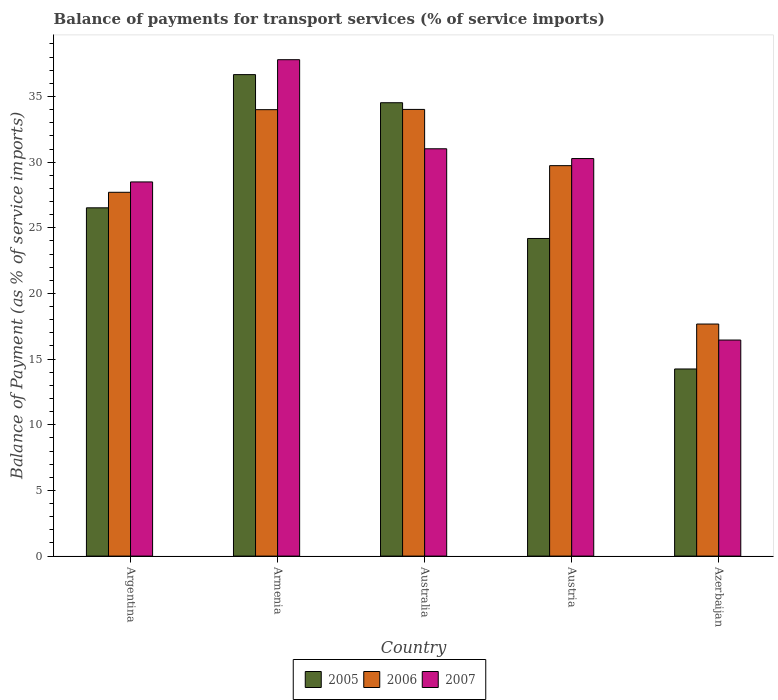How many different coloured bars are there?
Give a very brief answer. 3. How many groups of bars are there?
Provide a succinct answer. 5. How many bars are there on the 5th tick from the left?
Make the answer very short. 3. How many bars are there on the 5th tick from the right?
Provide a succinct answer. 3. What is the label of the 1st group of bars from the left?
Give a very brief answer. Argentina. In how many cases, is the number of bars for a given country not equal to the number of legend labels?
Keep it short and to the point. 0. What is the balance of payments for transport services in 2007 in Armenia?
Ensure brevity in your answer.  37.8. Across all countries, what is the maximum balance of payments for transport services in 2007?
Offer a very short reply. 37.8. Across all countries, what is the minimum balance of payments for transport services in 2005?
Ensure brevity in your answer.  14.25. In which country was the balance of payments for transport services in 2005 maximum?
Your answer should be compact. Armenia. In which country was the balance of payments for transport services in 2006 minimum?
Your response must be concise. Azerbaijan. What is the total balance of payments for transport services in 2006 in the graph?
Ensure brevity in your answer.  143.13. What is the difference between the balance of payments for transport services in 2007 in Australia and that in Austria?
Offer a very short reply. 0.74. What is the difference between the balance of payments for transport services in 2005 in Armenia and the balance of payments for transport services in 2006 in Austria?
Your answer should be very brief. 6.93. What is the average balance of payments for transport services in 2007 per country?
Provide a succinct answer. 28.81. What is the difference between the balance of payments for transport services of/in 2005 and balance of payments for transport services of/in 2006 in Australia?
Your answer should be very brief. 0.51. What is the ratio of the balance of payments for transport services in 2007 in Armenia to that in Austria?
Your answer should be compact. 1.25. Is the difference between the balance of payments for transport services in 2005 in Armenia and Austria greater than the difference between the balance of payments for transport services in 2006 in Armenia and Austria?
Ensure brevity in your answer.  Yes. What is the difference between the highest and the second highest balance of payments for transport services in 2005?
Your answer should be very brief. 8. What is the difference between the highest and the lowest balance of payments for transport services in 2006?
Provide a short and direct response. 16.34. In how many countries, is the balance of payments for transport services in 2006 greater than the average balance of payments for transport services in 2006 taken over all countries?
Offer a terse response. 3. Is the sum of the balance of payments for transport services in 2007 in Argentina and Australia greater than the maximum balance of payments for transport services in 2005 across all countries?
Make the answer very short. Yes. What does the 2nd bar from the left in Armenia represents?
Provide a short and direct response. 2006. Is it the case that in every country, the sum of the balance of payments for transport services in 2007 and balance of payments for transport services in 2006 is greater than the balance of payments for transport services in 2005?
Provide a succinct answer. Yes. Are all the bars in the graph horizontal?
Give a very brief answer. No. Does the graph contain any zero values?
Your answer should be very brief. No. How are the legend labels stacked?
Your answer should be very brief. Horizontal. What is the title of the graph?
Make the answer very short. Balance of payments for transport services (% of service imports). Does "1991" appear as one of the legend labels in the graph?
Offer a terse response. No. What is the label or title of the X-axis?
Your answer should be compact. Country. What is the label or title of the Y-axis?
Your response must be concise. Balance of Payment (as % of service imports). What is the Balance of Payment (as % of service imports) in 2005 in Argentina?
Provide a short and direct response. 26.52. What is the Balance of Payment (as % of service imports) in 2006 in Argentina?
Your answer should be compact. 27.71. What is the Balance of Payment (as % of service imports) of 2007 in Argentina?
Provide a short and direct response. 28.49. What is the Balance of Payment (as % of service imports) of 2005 in Armenia?
Give a very brief answer. 36.67. What is the Balance of Payment (as % of service imports) of 2006 in Armenia?
Keep it short and to the point. 34. What is the Balance of Payment (as % of service imports) of 2007 in Armenia?
Keep it short and to the point. 37.8. What is the Balance of Payment (as % of service imports) in 2005 in Australia?
Offer a very short reply. 34.53. What is the Balance of Payment (as % of service imports) of 2006 in Australia?
Provide a short and direct response. 34.02. What is the Balance of Payment (as % of service imports) of 2007 in Australia?
Your answer should be compact. 31.02. What is the Balance of Payment (as % of service imports) in 2005 in Austria?
Make the answer very short. 24.19. What is the Balance of Payment (as % of service imports) of 2006 in Austria?
Ensure brevity in your answer.  29.73. What is the Balance of Payment (as % of service imports) of 2007 in Austria?
Provide a succinct answer. 30.27. What is the Balance of Payment (as % of service imports) in 2005 in Azerbaijan?
Make the answer very short. 14.25. What is the Balance of Payment (as % of service imports) of 2006 in Azerbaijan?
Make the answer very short. 17.67. What is the Balance of Payment (as % of service imports) in 2007 in Azerbaijan?
Keep it short and to the point. 16.45. Across all countries, what is the maximum Balance of Payment (as % of service imports) of 2005?
Your answer should be very brief. 36.67. Across all countries, what is the maximum Balance of Payment (as % of service imports) of 2006?
Give a very brief answer. 34.02. Across all countries, what is the maximum Balance of Payment (as % of service imports) of 2007?
Offer a very short reply. 37.8. Across all countries, what is the minimum Balance of Payment (as % of service imports) of 2005?
Keep it short and to the point. 14.25. Across all countries, what is the minimum Balance of Payment (as % of service imports) in 2006?
Keep it short and to the point. 17.67. Across all countries, what is the minimum Balance of Payment (as % of service imports) of 2007?
Provide a short and direct response. 16.45. What is the total Balance of Payment (as % of service imports) in 2005 in the graph?
Offer a terse response. 136.15. What is the total Balance of Payment (as % of service imports) of 2006 in the graph?
Make the answer very short. 143.13. What is the total Balance of Payment (as % of service imports) in 2007 in the graph?
Offer a terse response. 144.05. What is the difference between the Balance of Payment (as % of service imports) in 2005 in Argentina and that in Armenia?
Your answer should be very brief. -10.14. What is the difference between the Balance of Payment (as % of service imports) of 2006 in Argentina and that in Armenia?
Offer a very short reply. -6.29. What is the difference between the Balance of Payment (as % of service imports) of 2007 in Argentina and that in Armenia?
Offer a terse response. -9.31. What is the difference between the Balance of Payment (as % of service imports) of 2005 in Argentina and that in Australia?
Make the answer very short. -8. What is the difference between the Balance of Payment (as % of service imports) of 2006 in Argentina and that in Australia?
Offer a terse response. -6.31. What is the difference between the Balance of Payment (as % of service imports) of 2007 in Argentina and that in Australia?
Your response must be concise. -2.53. What is the difference between the Balance of Payment (as % of service imports) of 2005 in Argentina and that in Austria?
Provide a succinct answer. 2.33. What is the difference between the Balance of Payment (as % of service imports) of 2006 in Argentina and that in Austria?
Keep it short and to the point. -2.03. What is the difference between the Balance of Payment (as % of service imports) of 2007 in Argentina and that in Austria?
Keep it short and to the point. -1.78. What is the difference between the Balance of Payment (as % of service imports) in 2005 in Argentina and that in Azerbaijan?
Keep it short and to the point. 12.27. What is the difference between the Balance of Payment (as % of service imports) in 2006 in Argentina and that in Azerbaijan?
Make the answer very short. 10.03. What is the difference between the Balance of Payment (as % of service imports) of 2007 in Argentina and that in Azerbaijan?
Offer a terse response. 12.04. What is the difference between the Balance of Payment (as % of service imports) in 2005 in Armenia and that in Australia?
Your answer should be compact. 2.14. What is the difference between the Balance of Payment (as % of service imports) in 2006 in Armenia and that in Australia?
Provide a short and direct response. -0.02. What is the difference between the Balance of Payment (as % of service imports) in 2007 in Armenia and that in Australia?
Keep it short and to the point. 6.78. What is the difference between the Balance of Payment (as % of service imports) in 2005 in Armenia and that in Austria?
Keep it short and to the point. 12.48. What is the difference between the Balance of Payment (as % of service imports) in 2006 in Armenia and that in Austria?
Ensure brevity in your answer.  4.26. What is the difference between the Balance of Payment (as % of service imports) of 2007 in Armenia and that in Austria?
Offer a very short reply. 7.53. What is the difference between the Balance of Payment (as % of service imports) of 2005 in Armenia and that in Azerbaijan?
Make the answer very short. 22.42. What is the difference between the Balance of Payment (as % of service imports) in 2006 in Armenia and that in Azerbaijan?
Give a very brief answer. 16.33. What is the difference between the Balance of Payment (as % of service imports) in 2007 in Armenia and that in Azerbaijan?
Ensure brevity in your answer.  21.35. What is the difference between the Balance of Payment (as % of service imports) of 2005 in Australia and that in Austria?
Offer a terse response. 10.34. What is the difference between the Balance of Payment (as % of service imports) in 2006 in Australia and that in Austria?
Your answer should be compact. 4.28. What is the difference between the Balance of Payment (as % of service imports) in 2007 in Australia and that in Austria?
Provide a short and direct response. 0.74. What is the difference between the Balance of Payment (as % of service imports) of 2005 in Australia and that in Azerbaijan?
Provide a short and direct response. 20.28. What is the difference between the Balance of Payment (as % of service imports) of 2006 in Australia and that in Azerbaijan?
Provide a succinct answer. 16.34. What is the difference between the Balance of Payment (as % of service imports) in 2007 in Australia and that in Azerbaijan?
Offer a very short reply. 14.57. What is the difference between the Balance of Payment (as % of service imports) of 2005 in Austria and that in Azerbaijan?
Your answer should be very brief. 9.94. What is the difference between the Balance of Payment (as % of service imports) of 2006 in Austria and that in Azerbaijan?
Give a very brief answer. 12.06. What is the difference between the Balance of Payment (as % of service imports) in 2007 in Austria and that in Azerbaijan?
Offer a terse response. 13.82. What is the difference between the Balance of Payment (as % of service imports) of 2005 in Argentina and the Balance of Payment (as % of service imports) of 2006 in Armenia?
Give a very brief answer. -7.47. What is the difference between the Balance of Payment (as % of service imports) of 2005 in Argentina and the Balance of Payment (as % of service imports) of 2007 in Armenia?
Provide a short and direct response. -11.28. What is the difference between the Balance of Payment (as % of service imports) of 2006 in Argentina and the Balance of Payment (as % of service imports) of 2007 in Armenia?
Your response must be concise. -10.1. What is the difference between the Balance of Payment (as % of service imports) in 2005 in Argentina and the Balance of Payment (as % of service imports) in 2006 in Australia?
Offer a very short reply. -7.49. What is the difference between the Balance of Payment (as % of service imports) in 2005 in Argentina and the Balance of Payment (as % of service imports) in 2007 in Australia?
Provide a succinct answer. -4.5. What is the difference between the Balance of Payment (as % of service imports) in 2006 in Argentina and the Balance of Payment (as % of service imports) in 2007 in Australia?
Keep it short and to the point. -3.31. What is the difference between the Balance of Payment (as % of service imports) of 2005 in Argentina and the Balance of Payment (as % of service imports) of 2006 in Austria?
Provide a succinct answer. -3.21. What is the difference between the Balance of Payment (as % of service imports) of 2005 in Argentina and the Balance of Payment (as % of service imports) of 2007 in Austria?
Your response must be concise. -3.75. What is the difference between the Balance of Payment (as % of service imports) in 2006 in Argentina and the Balance of Payment (as % of service imports) in 2007 in Austria?
Ensure brevity in your answer.  -2.57. What is the difference between the Balance of Payment (as % of service imports) of 2005 in Argentina and the Balance of Payment (as % of service imports) of 2006 in Azerbaijan?
Your answer should be very brief. 8.85. What is the difference between the Balance of Payment (as % of service imports) in 2005 in Argentina and the Balance of Payment (as % of service imports) in 2007 in Azerbaijan?
Keep it short and to the point. 10.07. What is the difference between the Balance of Payment (as % of service imports) of 2006 in Argentina and the Balance of Payment (as % of service imports) of 2007 in Azerbaijan?
Your answer should be compact. 11.25. What is the difference between the Balance of Payment (as % of service imports) in 2005 in Armenia and the Balance of Payment (as % of service imports) in 2006 in Australia?
Provide a short and direct response. 2.65. What is the difference between the Balance of Payment (as % of service imports) in 2005 in Armenia and the Balance of Payment (as % of service imports) in 2007 in Australia?
Make the answer very short. 5.65. What is the difference between the Balance of Payment (as % of service imports) in 2006 in Armenia and the Balance of Payment (as % of service imports) in 2007 in Australia?
Your response must be concise. 2.98. What is the difference between the Balance of Payment (as % of service imports) in 2005 in Armenia and the Balance of Payment (as % of service imports) in 2006 in Austria?
Provide a short and direct response. 6.93. What is the difference between the Balance of Payment (as % of service imports) in 2005 in Armenia and the Balance of Payment (as % of service imports) in 2007 in Austria?
Make the answer very short. 6.39. What is the difference between the Balance of Payment (as % of service imports) of 2006 in Armenia and the Balance of Payment (as % of service imports) of 2007 in Austria?
Keep it short and to the point. 3.72. What is the difference between the Balance of Payment (as % of service imports) of 2005 in Armenia and the Balance of Payment (as % of service imports) of 2006 in Azerbaijan?
Give a very brief answer. 18.99. What is the difference between the Balance of Payment (as % of service imports) in 2005 in Armenia and the Balance of Payment (as % of service imports) in 2007 in Azerbaijan?
Ensure brevity in your answer.  20.21. What is the difference between the Balance of Payment (as % of service imports) in 2006 in Armenia and the Balance of Payment (as % of service imports) in 2007 in Azerbaijan?
Your answer should be compact. 17.54. What is the difference between the Balance of Payment (as % of service imports) of 2005 in Australia and the Balance of Payment (as % of service imports) of 2006 in Austria?
Make the answer very short. 4.79. What is the difference between the Balance of Payment (as % of service imports) in 2005 in Australia and the Balance of Payment (as % of service imports) in 2007 in Austria?
Provide a short and direct response. 4.25. What is the difference between the Balance of Payment (as % of service imports) of 2006 in Australia and the Balance of Payment (as % of service imports) of 2007 in Austria?
Your response must be concise. 3.74. What is the difference between the Balance of Payment (as % of service imports) of 2005 in Australia and the Balance of Payment (as % of service imports) of 2006 in Azerbaijan?
Keep it short and to the point. 16.85. What is the difference between the Balance of Payment (as % of service imports) of 2005 in Australia and the Balance of Payment (as % of service imports) of 2007 in Azerbaijan?
Make the answer very short. 18.07. What is the difference between the Balance of Payment (as % of service imports) of 2006 in Australia and the Balance of Payment (as % of service imports) of 2007 in Azerbaijan?
Offer a terse response. 17.56. What is the difference between the Balance of Payment (as % of service imports) of 2005 in Austria and the Balance of Payment (as % of service imports) of 2006 in Azerbaijan?
Make the answer very short. 6.52. What is the difference between the Balance of Payment (as % of service imports) in 2005 in Austria and the Balance of Payment (as % of service imports) in 2007 in Azerbaijan?
Provide a short and direct response. 7.73. What is the difference between the Balance of Payment (as % of service imports) in 2006 in Austria and the Balance of Payment (as % of service imports) in 2007 in Azerbaijan?
Offer a very short reply. 13.28. What is the average Balance of Payment (as % of service imports) of 2005 per country?
Provide a short and direct response. 27.23. What is the average Balance of Payment (as % of service imports) of 2006 per country?
Your answer should be very brief. 28.63. What is the average Balance of Payment (as % of service imports) of 2007 per country?
Your answer should be compact. 28.81. What is the difference between the Balance of Payment (as % of service imports) in 2005 and Balance of Payment (as % of service imports) in 2006 in Argentina?
Your answer should be very brief. -1.18. What is the difference between the Balance of Payment (as % of service imports) in 2005 and Balance of Payment (as % of service imports) in 2007 in Argentina?
Offer a very short reply. -1.97. What is the difference between the Balance of Payment (as % of service imports) in 2006 and Balance of Payment (as % of service imports) in 2007 in Argentina?
Provide a succinct answer. -0.79. What is the difference between the Balance of Payment (as % of service imports) of 2005 and Balance of Payment (as % of service imports) of 2006 in Armenia?
Provide a succinct answer. 2.67. What is the difference between the Balance of Payment (as % of service imports) of 2005 and Balance of Payment (as % of service imports) of 2007 in Armenia?
Your answer should be compact. -1.14. What is the difference between the Balance of Payment (as % of service imports) in 2006 and Balance of Payment (as % of service imports) in 2007 in Armenia?
Offer a terse response. -3.8. What is the difference between the Balance of Payment (as % of service imports) of 2005 and Balance of Payment (as % of service imports) of 2006 in Australia?
Offer a very short reply. 0.51. What is the difference between the Balance of Payment (as % of service imports) of 2005 and Balance of Payment (as % of service imports) of 2007 in Australia?
Your answer should be very brief. 3.51. What is the difference between the Balance of Payment (as % of service imports) in 2006 and Balance of Payment (as % of service imports) in 2007 in Australia?
Provide a short and direct response. 3. What is the difference between the Balance of Payment (as % of service imports) of 2005 and Balance of Payment (as % of service imports) of 2006 in Austria?
Make the answer very short. -5.55. What is the difference between the Balance of Payment (as % of service imports) of 2005 and Balance of Payment (as % of service imports) of 2007 in Austria?
Give a very brief answer. -6.09. What is the difference between the Balance of Payment (as % of service imports) of 2006 and Balance of Payment (as % of service imports) of 2007 in Austria?
Ensure brevity in your answer.  -0.54. What is the difference between the Balance of Payment (as % of service imports) in 2005 and Balance of Payment (as % of service imports) in 2006 in Azerbaijan?
Ensure brevity in your answer.  -3.42. What is the difference between the Balance of Payment (as % of service imports) of 2005 and Balance of Payment (as % of service imports) of 2007 in Azerbaijan?
Provide a succinct answer. -2.2. What is the difference between the Balance of Payment (as % of service imports) of 2006 and Balance of Payment (as % of service imports) of 2007 in Azerbaijan?
Ensure brevity in your answer.  1.22. What is the ratio of the Balance of Payment (as % of service imports) of 2005 in Argentina to that in Armenia?
Your response must be concise. 0.72. What is the ratio of the Balance of Payment (as % of service imports) in 2006 in Argentina to that in Armenia?
Ensure brevity in your answer.  0.81. What is the ratio of the Balance of Payment (as % of service imports) in 2007 in Argentina to that in Armenia?
Offer a very short reply. 0.75. What is the ratio of the Balance of Payment (as % of service imports) in 2005 in Argentina to that in Australia?
Give a very brief answer. 0.77. What is the ratio of the Balance of Payment (as % of service imports) of 2006 in Argentina to that in Australia?
Keep it short and to the point. 0.81. What is the ratio of the Balance of Payment (as % of service imports) of 2007 in Argentina to that in Australia?
Make the answer very short. 0.92. What is the ratio of the Balance of Payment (as % of service imports) in 2005 in Argentina to that in Austria?
Offer a very short reply. 1.1. What is the ratio of the Balance of Payment (as % of service imports) in 2006 in Argentina to that in Austria?
Ensure brevity in your answer.  0.93. What is the ratio of the Balance of Payment (as % of service imports) in 2007 in Argentina to that in Austria?
Give a very brief answer. 0.94. What is the ratio of the Balance of Payment (as % of service imports) in 2005 in Argentina to that in Azerbaijan?
Your response must be concise. 1.86. What is the ratio of the Balance of Payment (as % of service imports) in 2006 in Argentina to that in Azerbaijan?
Offer a very short reply. 1.57. What is the ratio of the Balance of Payment (as % of service imports) of 2007 in Argentina to that in Azerbaijan?
Your answer should be very brief. 1.73. What is the ratio of the Balance of Payment (as % of service imports) of 2005 in Armenia to that in Australia?
Ensure brevity in your answer.  1.06. What is the ratio of the Balance of Payment (as % of service imports) in 2006 in Armenia to that in Australia?
Make the answer very short. 1. What is the ratio of the Balance of Payment (as % of service imports) of 2007 in Armenia to that in Australia?
Your answer should be very brief. 1.22. What is the ratio of the Balance of Payment (as % of service imports) in 2005 in Armenia to that in Austria?
Your answer should be very brief. 1.52. What is the ratio of the Balance of Payment (as % of service imports) of 2006 in Armenia to that in Austria?
Offer a very short reply. 1.14. What is the ratio of the Balance of Payment (as % of service imports) in 2007 in Armenia to that in Austria?
Your response must be concise. 1.25. What is the ratio of the Balance of Payment (as % of service imports) of 2005 in Armenia to that in Azerbaijan?
Offer a terse response. 2.57. What is the ratio of the Balance of Payment (as % of service imports) of 2006 in Armenia to that in Azerbaijan?
Give a very brief answer. 1.92. What is the ratio of the Balance of Payment (as % of service imports) in 2007 in Armenia to that in Azerbaijan?
Keep it short and to the point. 2.3. What is the ratio of the Balance of Payment (as % of service imports) in 2005 in Australia to that in Austria?
Make the answer very short. 1.43. What is the ratio of the Balance of Payment (as % of service imports) of 2006 in Australia to that in Austria?
Your answer should be very brief. 1.14. What is the ratio of the Balance of Payment (as % of service imports) in 2007 in Australia to that in Austria?
Give a very brief answer. 1.02. What is the ratio of the Balance of Payment (as % of service imports) in 2005 in Australia to that in Azerbaijan?
Your answer should be very brief. 2.42. What is the ratio of the Balance of Payment (as % of service imports) of 2006 in Australia to that in Azerbaijan?
Your response must be concise. 1.92. What is the ratio of the Balance of Payment (as % of service imports) in 2007 in Australia to that in Azerbaijan?
Ensure brevity in your answer.  1.89. What is the ratio of the Balance of Payment (as % of service imports) in 2005 in Austria to that in Azerbaijan?
Offer a terse response. 1.7. What is the ratio of the Balance of Payment (as % of service imports) of 2006 in Austria to that in Azerbaijan?
Provide a succinct answer. 1.68. What is the ratio of the Balance of Payment (as % of service imports) of 2007 in Austria to that in Azerbaijan?
Ensure brevity in your answer.  1.84. What is the difference between the highest and the second highest Balance of Payment (as % of service imports) in 2005?
Offer a terse response. 2.14. What is the difference between the highest and the second highest Balance of Payment (as % of service imports) in 2006?
Ensure brevity in your answer.  0.02. What is the difference between the highest and the second highest Balance of Payment (as % of service imports) in 2007?
Provide a short and direct response. 6.78. What is the difference between the highest and the lowest Balance of Payment (as % of service imports) of 2005?
Your answer should be compact. 22.42. What is the difference between the highest and the lowest Balance of Payment (as % of service imports) in 2006?
Your answer should be very brief. 16.34. What is the difference between the highest and the lowest Balance of Payment (as % of service imports) of 2007?
Give a very brief answer. 21.35. 